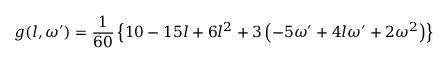Convert formula to latex. <formula><loc_0><loc_0><loc_500><loc_500>g ( l , \omega ^ { \prime } ) = \frac { 1 } { 6 0 } \left \{ 1 0 - 1 5 l + 6 l ^ { 2 } + 3 \left ( - 5 \omega ^ { \prime } + 4 l \omega ^ { \prime } + 2 \omega ^ { 2 } \right ) \right \}</formula> 